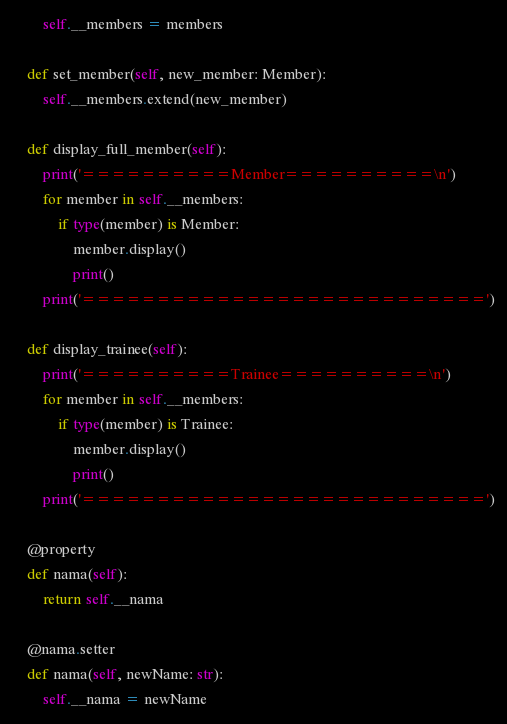Convert code to text. <code><loc_0><loc_0><loc_500><loc_500><_Python_>        self.__members = members

    def set_member(self, new_member: Member):
        self.__members.extend(new_member)

    def display_full_member(self):
        print('==========Member==========\n')
        for member in self.__members:
            if type(member) is Member:
                member.display()
                print()
        print('===========================')

    def display_trainee(self):
        print('==========Trainee==========\n')
        for member in self.__members:
            if type(member) is Trainee:
                member.display()
                print()
        print('===========================')

    @property
    def nama(self):
        return self.__nama

    @nama.setter
    def nama(self, newName: str):
        self.__nama = newName
</code> 